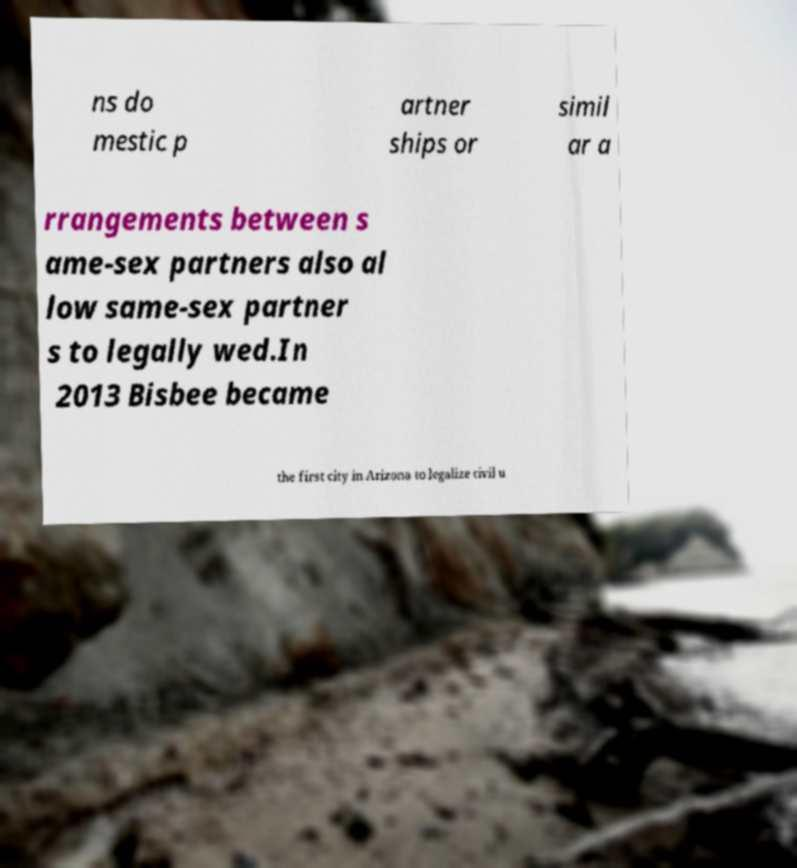What messages or text are displayed in this image? I need them in a readable, typed format. ns do mestic p artner ships or simil ar a rrangements between s ame-sex partners also al low same-sex partner s to legally wed.In 2013 Bisbee became the first city in Arizona to legalize civil u 